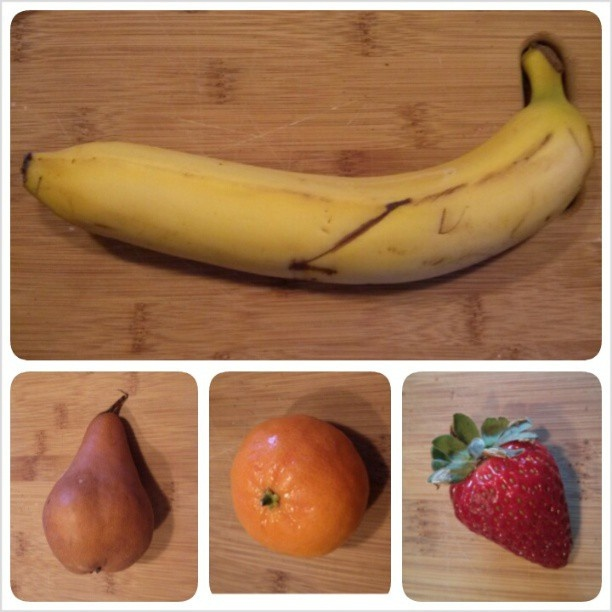Describe the objects in this image and their specific colors. I can see dining table in lightgray, gray, brown, and tan tones, banana in lightgray, tan, olive, and maroon tones, dining table in lightgray, tan, gray, darkgray, and maroon tones, dining table in lightgray, gray, brown, red, and maroon tones, and orange in lightgray, red, brown, maroon, and salmon tones in this image. 